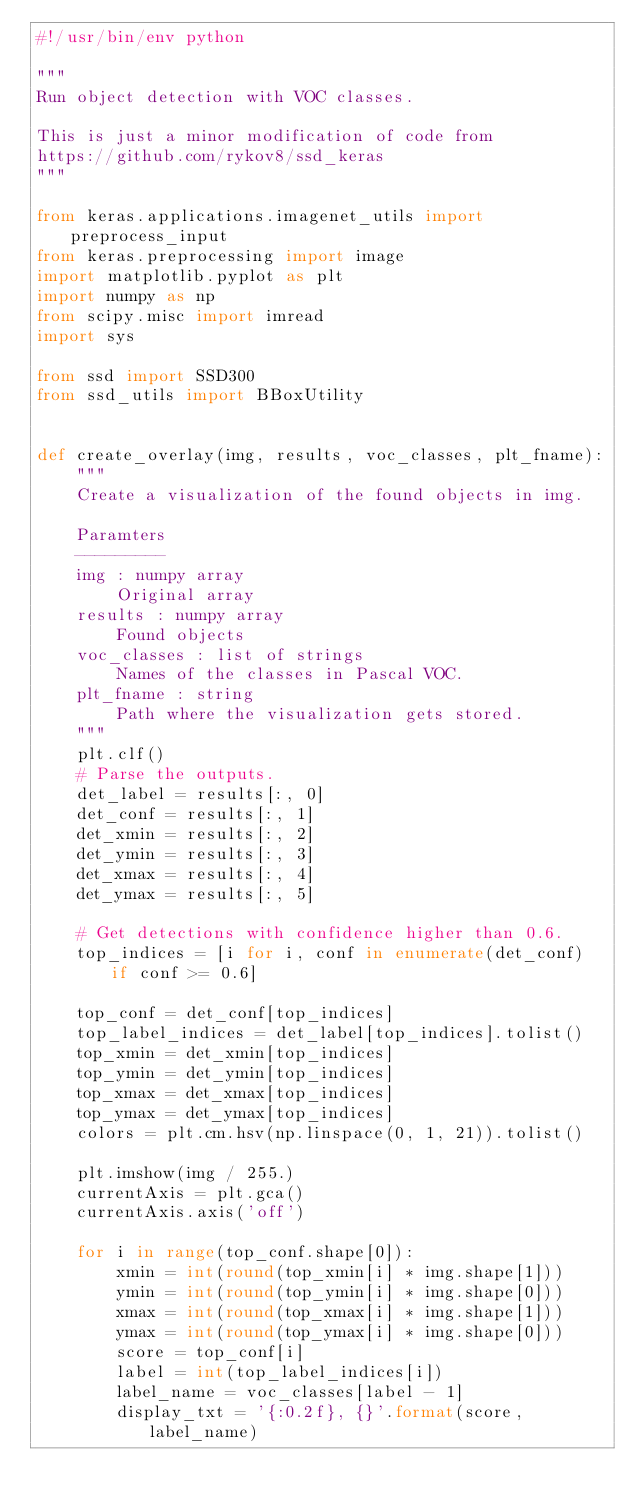Convert code to text. <code><loc_0><loc_0><loc_500><loc_500><_Python_>#!/usr/bin/env python

"""
Run object detection with VOC classes.

This is just a minor modification of code from
https://github.com/rykov8/ssd_keras
"""

from keras.applications.imagenet_utils import preprocess_input
from keras.preprocessing import image
import matplotlib.pyplot as plt
import numpy as np
from scipy.misc import imread
import sys

from ssd import SSD300
from ssd_utils import BBoxUtility


def create_overlay(img, results, voc_classes, plt_fname):
    """
    Create a visualization of the found objects in img.

    Paramters
    ---------
    img : numpy array
        Original array
    results : numpy array
        Found objects
    voc_classes : list of strings
        Names of the classes in Pascal VOC.
    plt_fname : string
        Path where the visualization gets stored.
    """
    plt.clf()
    # Parse the outputs.
    det_label = results[:, 0]
    det_conf = results[:, 1]
    det_xmin = results[:, 2]
    det_ymin = results[:, 3]
    det_xmax = results[:, 4]
    det_ymax = results[:, 5]

    # Get detections with confidence higher than 0.6.
    top_indices = [i for i, conf in enumerate(det_conf) if conf >= 0.6]

    top_conf = det_conf[top_indices]
    top_label_indices = det_label[top_indices].tolist()
    top_xmin = det_xmin[top_indices]
    top_ymin = det_ymin[top_indices]
    top_xmax = det_xmax[top_indices]
    top_ymax = det_ymax[top_indices]
    colors = plt.cm.hsv(np.linspace(0, 1, 21)).tolist()

    plt.imshow(img / 255.)
    currentAxis = plt.gca()
    currentAxis.axis('off')

    for i in range(top_conf.shape[0]):
        xmin = int(round(top_xmin[i] * img.shape[1]))
        ymin = int(round(top_ymin[i] * img.shape[0]))
        xmax = int(round(top_xmax[i] * img.shape[1]))
        ymax = int(round(top_ymax[i] * img.shape[0]))
        score = top_conf[i]
        label = int(top_label_indices[i])
        label_name = voc_classes[label - 1]
        display_txt = '{:0.2f}, {}'.format(score, label_name)</code> 